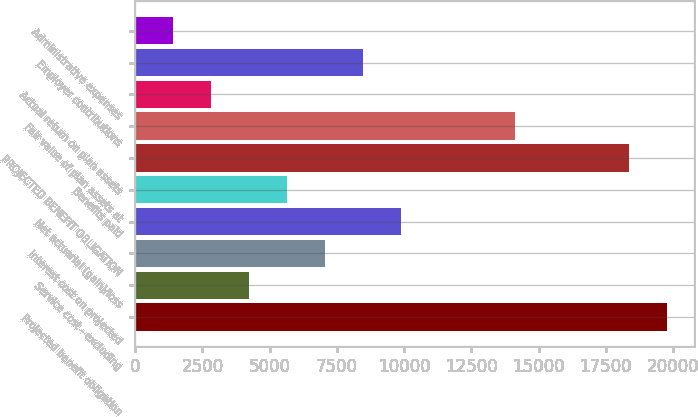Convert chart. <chart><loc_0><loc_0><loc_500><loc_500><bar_chart><fcel>Projected benefit obligation<fcel>Service cost - excluding<fcel>Interest cost on projected<fcel>Net actuarial (gain)/loss<fcel>Benefits paid<fcel>PROJECTED BENEFIT OBLIGATION<fcel>Fair value of plan assets at<fcel>Actual return on plan assets<fcel>Employer contributions<fcel>Administrative expenses<nl><fcel>19790.6<fcel>4243.2<fcel>7070<fcel>9896.8<fcel>5656.6<fcel>18377.2<fcel>14137<fcel>2829.8<fcel>8483.4<fcel>1416.4<nl></chart> 